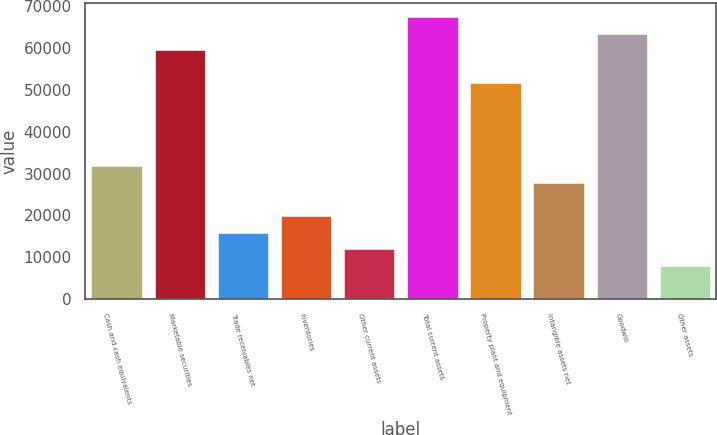Convert chart to OTSL. <chart><loc_0><loc_0><loc_500><loc_500><bar_chart><fcel>Cash and cash equivalents<fcel>Marketable securities<fcel>Trade receivables net<fcel>Inventories<fcel>Other current assets<fcel>Total current assets<fcel>Property plant and equipment<fcel>Intangible assets net<fcel>Goodwill<fcel>Other assets<nl><fcel>31712.2<fcel>59421<fcel>15878.6<fcel>19837<fcel>11920.2<fcel>67337.8<fcel>51504.2<fcel>27753.8<fcel>63379.4<fcel>7961.8<nl></chart> 